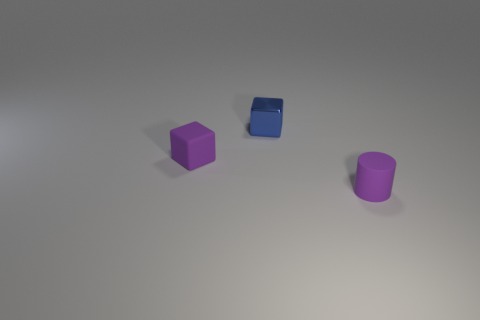Add 3 tiny purple metallic blocks. How many objects exist? 6 Subtract 1 cylinders. How many cylinders are left? 0 Subtract all green blocks. Subtract all cyan cylinders. How many blocks are left? 2 Subtract all blue spheres. How many purple blocks are left? 1 Subtract all big green cubes. Subtract all small blue things. How many objects are left? 2 Add 1 metallic blocks. How many metallic blocks are left? 2 Add 2 tiny purple blocks. How many tiny purple blocks exist? 3 Subtract 0 purple balls. How many objects are left? 3 Subtract all blocks. How many objects are left? 1 